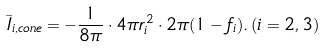<formula> <loc_0><loc_0><loc_500><loc_500>\bar { I } _ { i , c o n e } = - \frac { 1 } { 8 \pi } \cdot 4 \pi r _ { i } ^ { 2 } \cdot 2 \pi ( 1 - f _ { i } ) . \, ( i = 2 , 3 )</formula> 